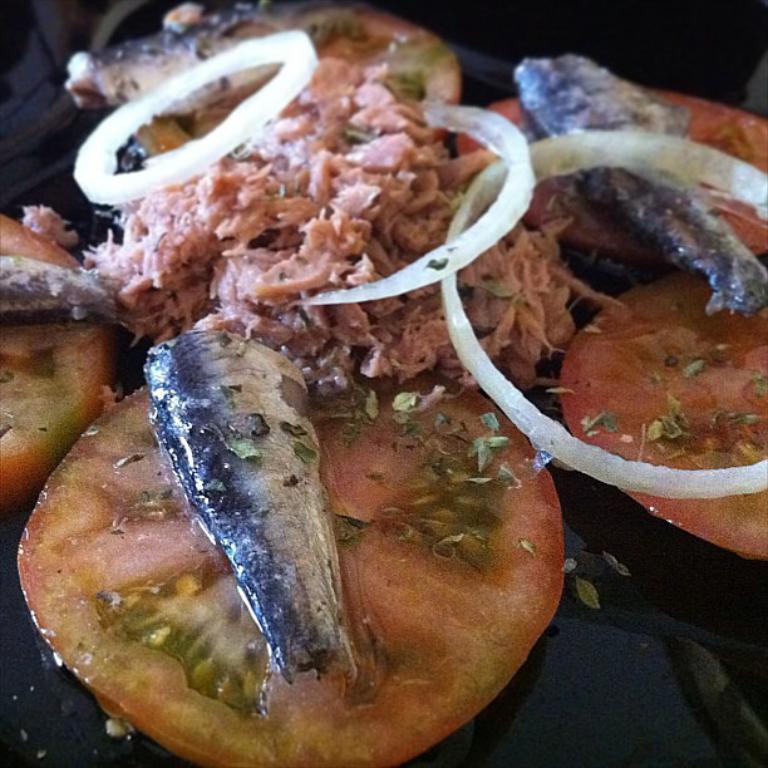Can you describe this image briefly? In this image I can see the food on the black color table. The food is in brown color. 